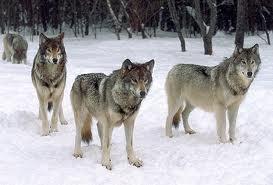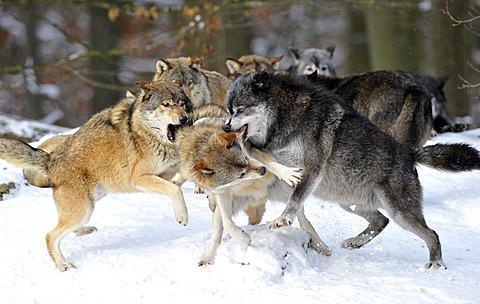The first image is the image on the left, the second image is the image on the right. Examine the images to the left and right. Is the description "Some of the dogs are howling with their heads pointed up." accurate? Answer yes or no. No. The first image is the image on the left, the second image is the image on the right. Considering the images on both sides, is "An image shows at least four wolves posed right by a large upright tree trunk." valid? Answer yes or no. No. 